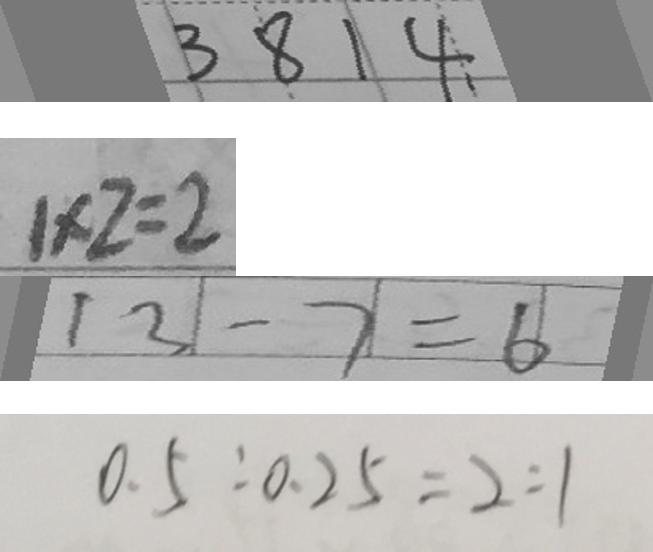Convert formula to latex. <formula><loc_0><loc_0><loc_500><loc_500>3 8 1 4 
 1 \times 2 = 2 
 1 3 - 7 = 6 
 0 . 5 : 0 . 2 5 = 2 : 1</formula> 